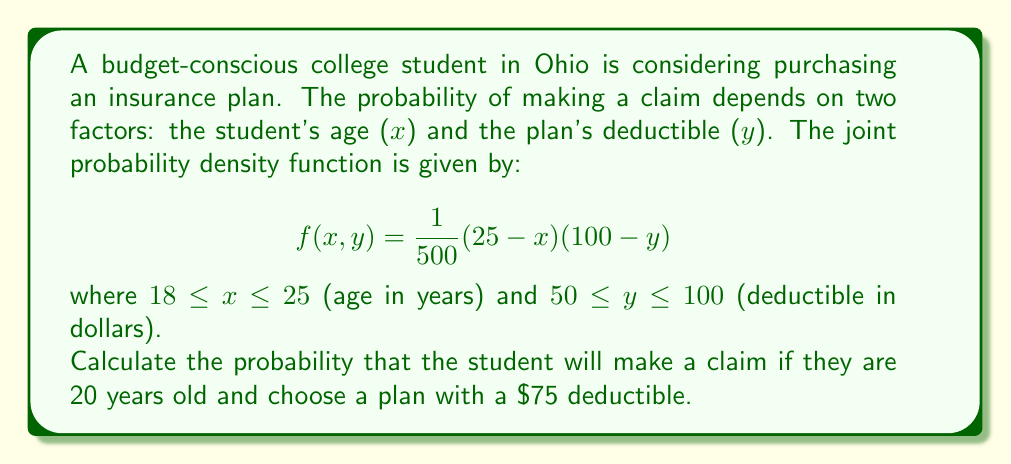Can you solve this math problem? To solve this problem, we need to use multivariable calculus, specifically double integrals. The probability of making a claim given specific values of $x$ and $y$ is found by integrating the joint probability density function over the entire domain.

1) First, we need to set up the double integral:

   $$P(\text{claim}) = \int_{18}^{25} \int_{50}^{100} f(x,y) \, dy \, dx$$

2) Substitute the given function:

   $$P(\text{claim}) = \int_{18}^{25} \int_{50}^{100} \frac{1}{500}(25-x)(100-y) \, dy \, dx$$

3) However, we're given specific values for $x$ and $y$: $x = 20$ and $y = 75$. This means we don't need to integrate over the entire domain. Instead, we can simply evaluate the function at these points:

   $$P(\text{claim}) = f(20, 75) = \frac{1}{500}(25-20)(100-75) = \frac{1}{500}(5)(25) = \frac{1}{4}$$

4) Therefore, the probability of making a claim given the student is 20 years old and chooses a plan with a $75 deductible is 1/4 or 0.25 or 25%.
Answer: $\frac{1}{4}$ or 0.25 or 25% 